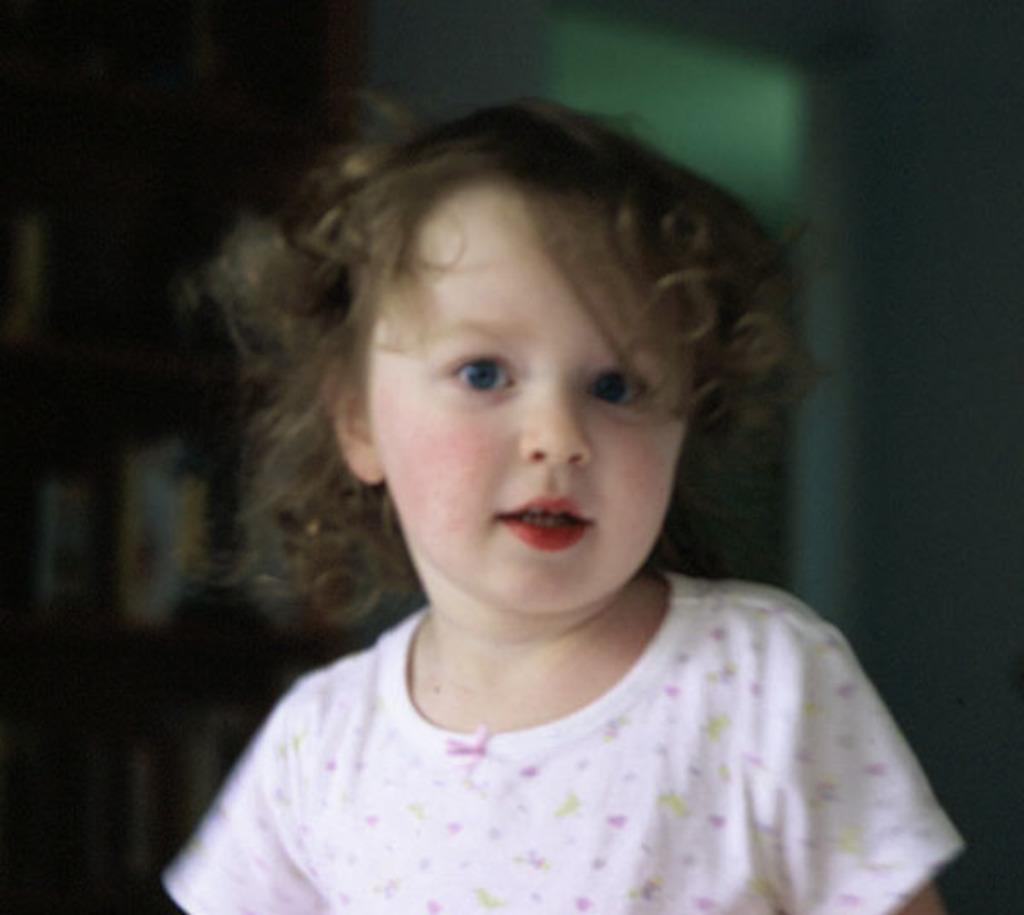What is the main subject of the image? There is a baby in the image. Can you describe the background of the image? The background of the image is blurred. What type of rifle can be seen in the image? There is no rifle present in the image. How many feet are visible in the image? There are no feet visible in the image. 